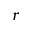<formula> <loc_0><loc_0><loc_500><loc_500>r</formula> 